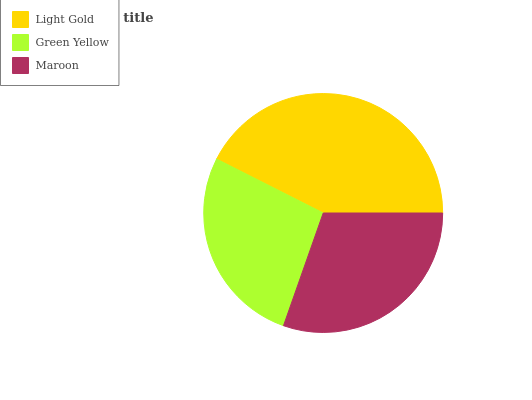Is Green Yellow the minimum?
Answer yes or no. Yes. Is Light Gold the maximum?
Answer yes or no. Yes. Is Maroon the minimum?
Answer yes or no. No. Is Maroon the maximum?
Answer yes or no. No. Is Maroon greater than Green Yellow?
Answer yes or no. Yes. Is Green Yellow less than Maroon?
Answer yes or no. Yes. Is Green Yellow greater than Maroon?
Answer yes or no. No. Is Maroon less than Green Yellow?
Answer yes or no. No. Is Maroon the high median?
Answer yes or no. Yes. Is Maroon the low median?
Answer yes or no. Yes. Is Green Yellow the high median?
Answer yes or no. No. Is Light Gold the low median?
Answer yes or no. No. 